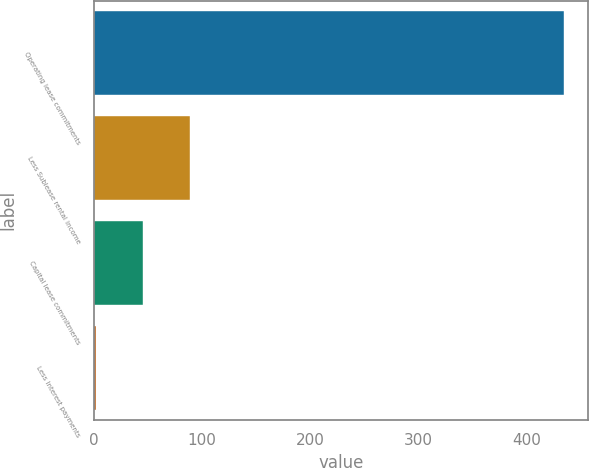<chart> <loc_0><loc_0><loc_500><loc_500><bar_chart><fcel>Operating lease commitments<fcel>Less Sublease rental income<fcel>Capital lease commitments<fcel>Less Interest payments<nl><fcel>435<fcel>88.6<fcel>45.3<fcel>2<nl></chart> 